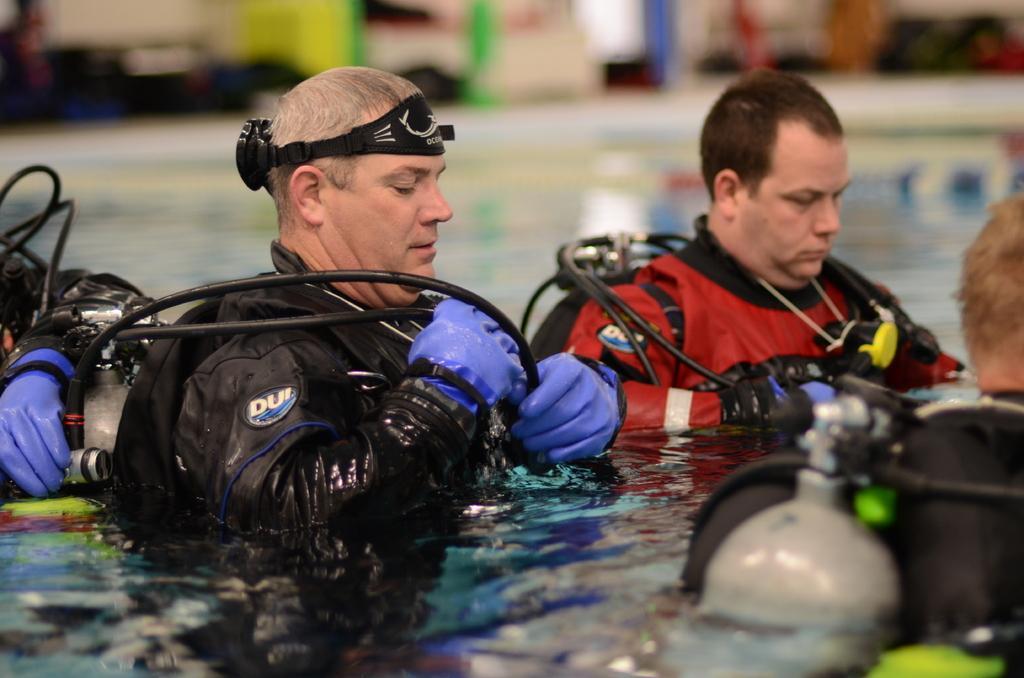Describe this image in one or two sentences. In this picture, there are four people standing in the water. All the men are wearing jackets and carrying gas cylinders. 